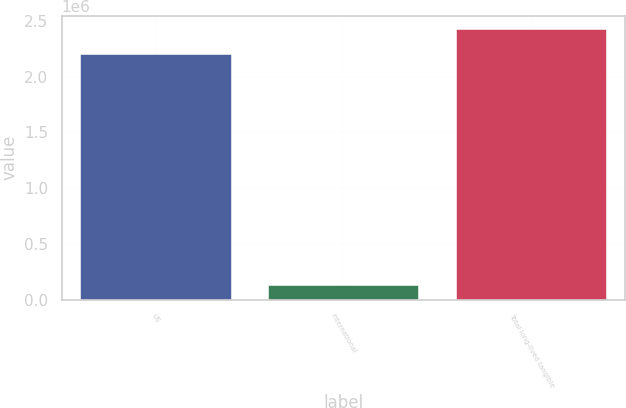Convert chart. <chart><loc_0><loc_0><loc_500><loc_500><bar_chart><fcel>US<fcel>International<fcel>Total long-lived tangible<nl><fcel>2.20263e+06<fcel>128151<fcel>2.42289e+06<nl></chart> 